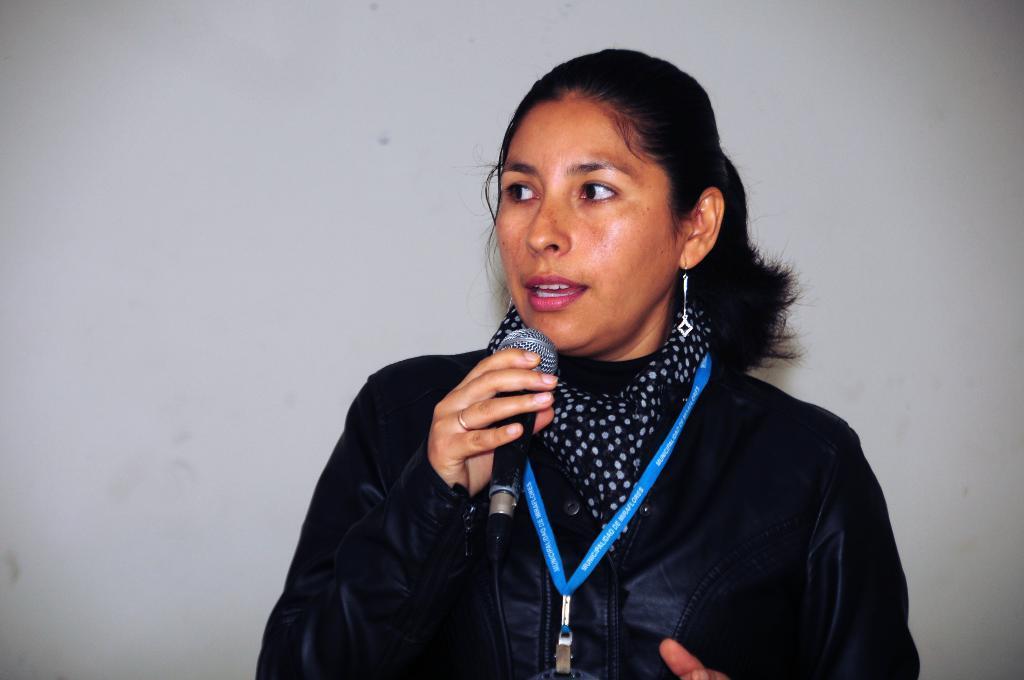Please provide a concise description of this image. A lady wearing a black jacket and tag holding a mic and speaking. 